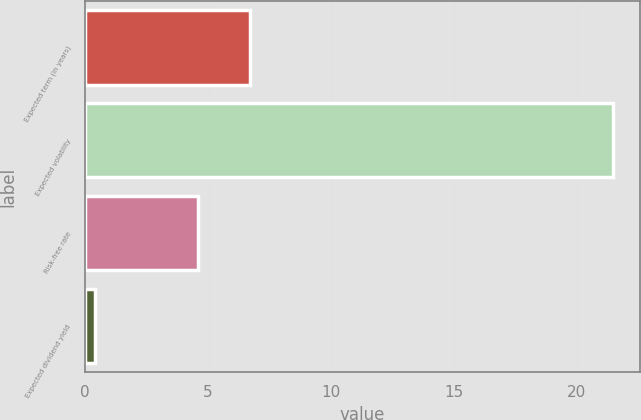<chart> <loc_0><loc_0><loc_500><loc_500><bar_chart><fcel>Expected term (in years)<fcel>Expected volatility<fcel>Risk-free rate<fcel>Expected dividend yield<nl><fcel>6.71<fcel>21.5<fcel>4.6<fcel>0.4<nl></chart> 